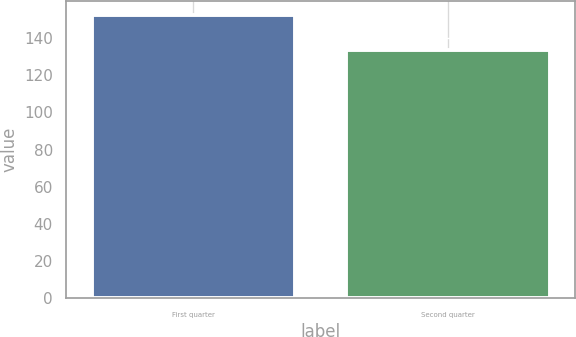Convert chart to OTSL. <chart><loc_0><loc_0><loc_500><loc_500><bar_chart><fcel>First quarter<fcel>Second quarter<nl><fcel>152.36<fcel>133.53<nl></chart> 